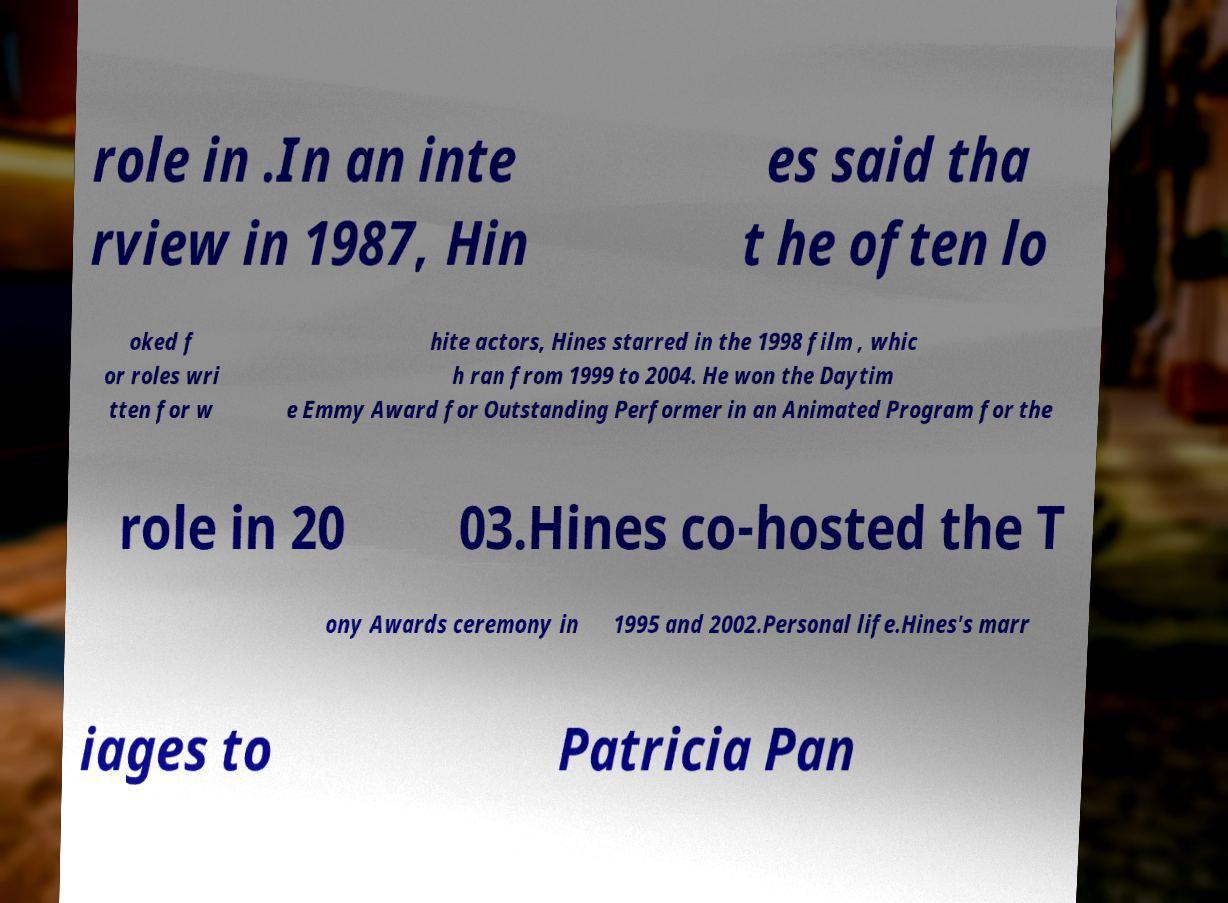Can you accurately transcribe the text from the provided image for me? role in .In an inte rview in 1987, Hin es said tha t he often lo oked f or roles wri tten for w hite actors, Hines starred in the 1998 film , whic h ran from 1999 to 2004. He won the Daytim e Emmy Award for Outstanding Performer in an Animated Program for the role in 20 03.Hines co-hosted the T ony Awards ceremony in 1995 and 2002.Personal life.Hines's marr iages to Patricia Pan 